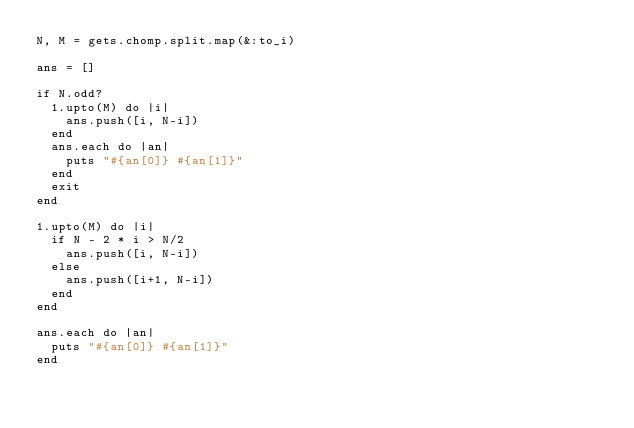Convert code to text. <code><loc_0><loc_0><loc_500><loc_500><_Ruby_>N, M = gets.chomp.split.map(&:to_i)

ans = []

if N.odd?
  1.upto(M) do |i|
    ans.push([i, N-i])
  end
  ans.each do |an|
    puts "#{an[0]} #{an[1]}"
  end
  exit
end

1.upto(M) do |i|
  if N - 2 * i > N/2
    ans.push([i, N-i])
  else
    ans.push([i+1, N-i])
  end
end

ans.each do |an|
  puts "#{an[0]} #{an[1]}"
end
</code> 